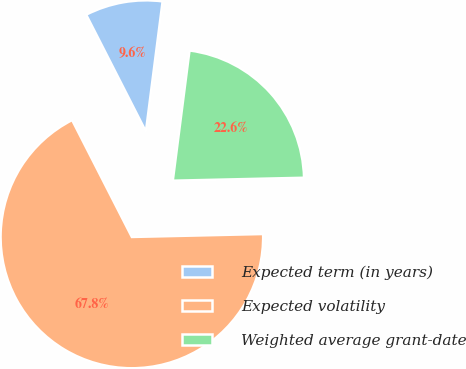<chart> <loc_0><loc_0><loc_500><loc_500><pie_chart><fcel>Expected term (in years)<fcel>Expected volatility<fcel>Weighted average grant-date<nl><fcel>9.55%<fcel>67.84%<fcel>22.61%<nl></chart> 